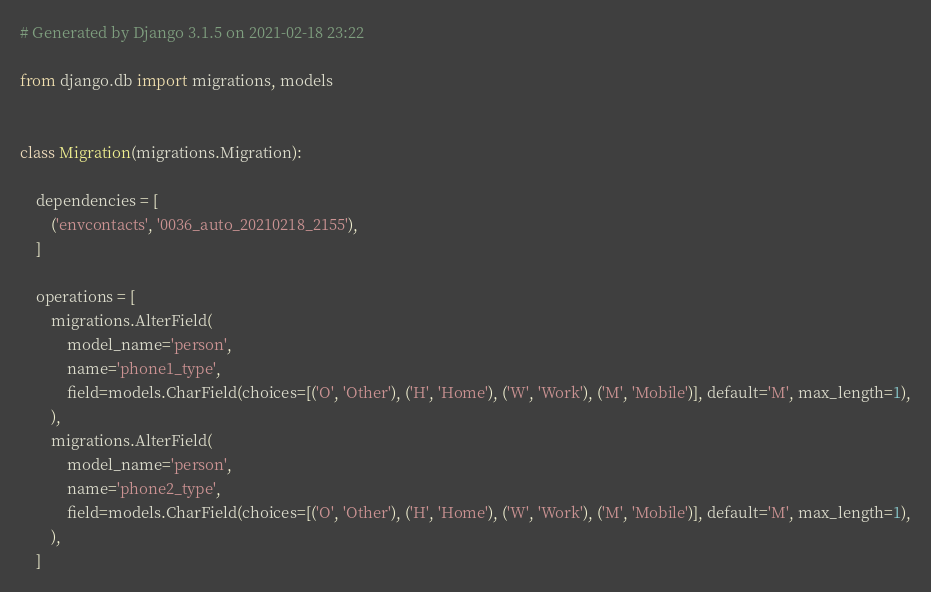<code> <loc_0><loc_0><loc_500><loc_500><_Python_># Generated by Django 3.1.5 on 2021-02-18 23:22

from django.db import migrations, models


class Migration(migrations.Migration):

    dependencies = [
        ('envcontacts', '0036_auto_20210218_2155'),
    ]

    operations = [
        migrations.AlterField(
            model_name='person',
            name='phone1_type',
            field=models.CharField(choices=[('O', 'Other'), ('H', 'Home'), ('W', 'Work'), ('M', 'Mobile')], default='M', max_length=1),
        ),
        migrations.AlterField(
            model_name='person',
            name='phone2_type',
            field=models.CharField(choices=[('O', 'Other'), ('H', 'Home'), ('W', 'Work'), ('M', 'Mobile')], default='M', max_length=1),
        ),
    ]
</code> 